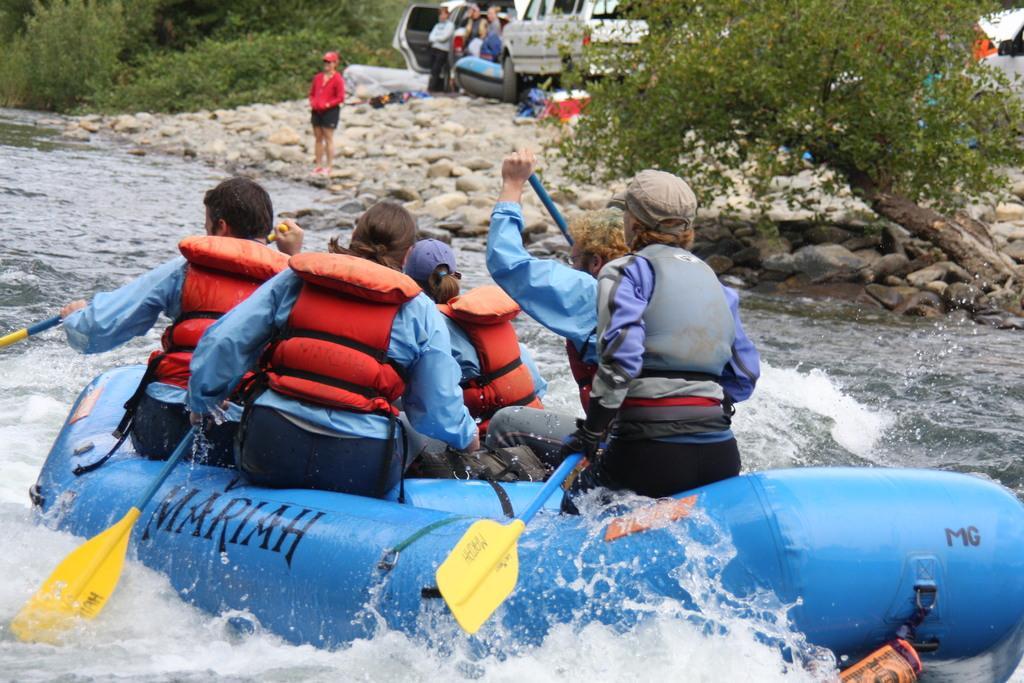How would you summarize this image in a sentence or two? In this picture I can see some people riding a boat and holding the sticks. At the top I can see some group of persons who are sitting and standing near to the car. At the top there is a woman who is standing near to the water flow. In the top left and top right I can see the trees and plants. On the right I can see some stones. 